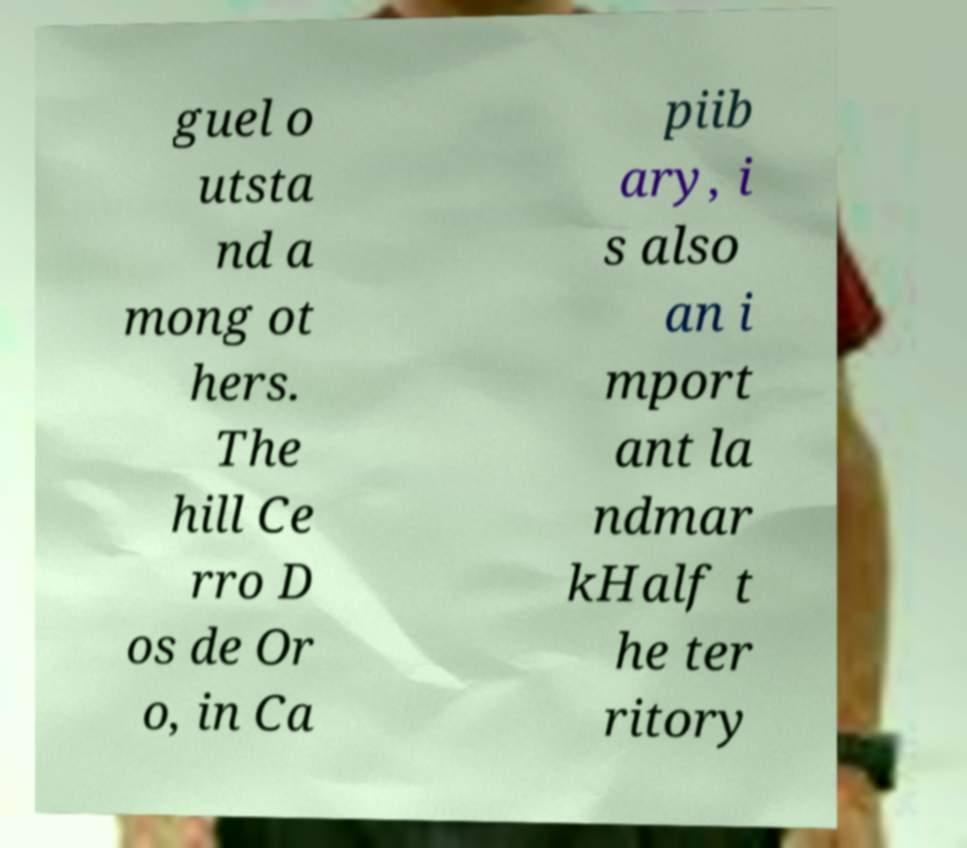Could you extract and type out the text from this image? guel o utsta nd a mong ot hers. The hill Ce rro D os de Or o, in Ca piib ary, i s also an i mport ant la ndmar kHalf t he ter ritory 